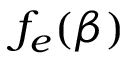Convert formula to latex. <formula><loc_0><loc_0><loc_500><loc_500>f _ { e } ( \beta )</formula> 